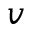<formula> <loc_0><loc_0><loc_500><loc_500>v</formula> 